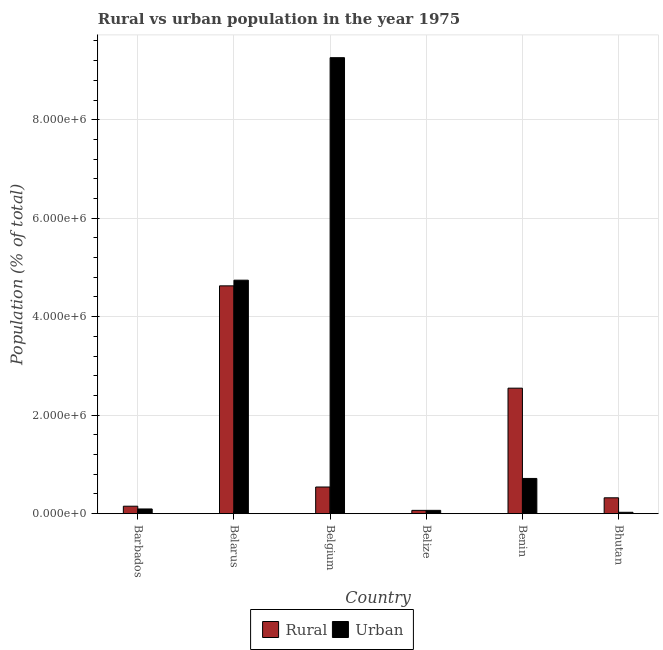How many different coloured bars are there?
Offer a terse response. 2. How many groups of bars are there?
Make the answer very short. 6. Are the number of bars on each tick of the X-axis equal?
Your response must be concise. Yes. How many bars are there on the 2nd tick from the left?
Your answer should be very brief. 2. What is the label of the 4th group of bars from the left?
Offer a terse response. Belize. What is the urban population density in Belarus?
Your answer should be very brief. 4.74e+06. Across all countries, what is the maximum urban population density?
Make the answer very short. 9.26e+06. Across all countries, what is the minimum urban population density?
Offer a terse response. 2.75e+04. In which country was the rural population density maximum?
Give a very brief answer. Belarus. In which country was the urban population density minimum?
Keep it short and to the point. Bhutan. What is the total urban population density in the graph?
Ensure brevity in your answer.  1.49e+07. What is the difference between the rural population density in Barbados and that in Belgium?
Offer a terse response. -3.90e+05. What is the difference between the rural population density in Benin and the urban population density in Belarus?
Make the answer very short. -2.19e+06. What is the average rural population density per country?
Ensure brevity in your answer.  1.38e+06. What is the difference between the urban population density and rural population density in Barbados?
Provide a short and direct response. -5.60e+04. What is the ratio of the urban population density in Barbados to that in Belgium?
Your answer should be very brief. 0.01. Is the rural population density in Benin less than that in Bhutan?
Offer a terse response. No. What is the difference between the highest and the second highest urban population density?
Ensure brevity in your answer.  4.52e+06. What is the difference between the highest and the lowest urban population density?
Your response must be concise. 9.23e+06. What does the 2nd bar from the left in Belgium represents?
Keep it short and to the point. Urban. What does the 2nd bar from the right in Bhutan represents?
Your response must be concise. Rural. How many bars are there?
Your answer should be very brief. 12. What is the difference between two consecutive major ticks on the Y-axis?
Keep it short and to the point. 2.00e+06. Does the graph contain grids?
Keep it short and to the point. Yes. Where does the legend appear in the graph?
Your answer should be very brief. Bottom center. What is the title of the graph?
Make the answer very short. Rural vs urban population in the year 1975. Does "From Government" appear as one of the legend labels in the graph?
Ensure brevity in your answer.  No. What is the label or title of the X-axis?
Ensure brevity in your answer.  Country. What is the label or title of the Y-axis?
Provide a succinct answer. Population (% of total). What is the Population (% of total) of Rural in Barbados?
Your answer should be very brief. 1.51e+05. What is the Population (% of total) in Urban in Barbados?
Make the answer very short. 9.50e+04. What is the Population (% of total) in Rural in Belarus?
Give a very brief answer. 4.63e+06. What is the Population (% of total) in Urban in Belarus?
Offer a very short reply. 4.74e+06. What is the Population (% of total) in Rural in Belgium?
Your response must be concise. 5.41e+05. What is the Population (% of total) of Urban in Belgium?
Keep it short and to the point. 9.26e+06. What is the Population (% of total) of Rural in Belize?
Your response must be concise. 6.64e+04. What is the Population (% of total) of Urban in Belize?
Your response must be concise. 6.69e+04. What is the Population (% of total) in Rural in Benin?
Your answer should be compact. 2.55e+06. What is the Population (% of total) in Urban in Benin?
Provide a short and direct response. 7.15e+05. What is the Population (% of total) of Rural in Bhutan?
Offer a terse response. 3.22e+05. What is the Population (% of total) in Urban in Bhutan?
Provide a short and direct response. 2.75e+04. Across all countries, what is the maximum Population (% of total) in Rural?
Your answer should be compact. 4.63e+06. Across all countries, what is the maximum Population (% of total) in Urban?
Provide a succinct answer. 9.26e+06. Across all countries, what is the minimum Population (% of total) in Rural?
Your answer should be compact. 6.64e+04. Across all countries, what is the minimum Population (% of total) in Urban?
Your response must be concise. 2.75e+04. What is the total Population (% of total) in Rural in the graph?
Ensure brevity in your answer.  8.25e+06. What is the total Population (% of total) in Urban in the graph?
Make the answer very short. 1.49e+07. What is the difference between the Population (% of total) in Rural in Barbados and that in Belarus?
Provide a short and direct response. -4.47e+06. What is the difference between the Population (% of total) of Urban in Barbados and that in Belarus?
Your response must be concise. -4.65e+06. What is the difference between the Population (% of total) in Rural in Barbados and that in Belgium?
Offer a terse response. -3.90e+05. What is the difference between the Population (% of total) of Urban in Barbados and that in Belgium?
Your answer should be very brief. -9.16e+06. What is the difference between the Population (% of total) of Rural in Barbados and that in Belize?
Make the answer very short. 8.46e+04. What is the difference between the Population (% of total) of Urban in Barbados and that in Belize?
Provide a succinct answer. 2.82e+04. What is the difference between the Population (% of total) of Rural in Barbados and that in Benin?
Offer a very short reply. -2.40e+06. What is the difference between the Population (% of total) of Urban in Barbados and that in Benin?
Provide a short and direct response. -6.20e+05. What is the difference between the Population (% of total) in Rural in Barbados and that in Bhutan?
Keep it short and to the point. -1.71e+05. What is the difference between the Population (% of total) in Urban in Barbados and that in Bhutan?
Your answer should be compact. 6.75e+04. What is the difference between the Population (% of total) in Rural in Belarus and that in Belgium?
Your response must be concise. 4.08e+06. What is the difference between the Population (% of total) of Urban in Belarus and that in Belgium?
Your answer should be compact. -4.52e+06. What is the difference between the Population (% of total) of Rural in Belarus and that in Belize?
Offer a terse response. 4.56e+06. What is the difference between the Population (% of total) in Urban in Belarus and that in Belize?
Make the answer very short. 4.67e+06. What is the difference between the Population (% of total) of Rural in Belarus and that in Benin?
Ensure brevity in your answer.  2.08e+06. What is the difference between the Population (% of total) of Urban in Belarus and that in Benin?
Offer a very short reply. 4.03e+06. What is the difference between the Population (% of total) of Rural in Belarus and that in Bhutan?
Give a very brief answer. 4.30e+06. What is the difference between the Population (% of total) in Urban in Belarus and that in Bhutan?
Provide a succinct answer. 4.71e+06. What is the difference between the Population (% of total) in Rural in Belgium and that in Belize?
Your answer should be compact. 4.75e+05. What is the difference between the Population (% of total) in Urban in Belgium and that in Belize?
Ensure brevity in your answer.  9.19e+06. What is the difference between the Population (% of total) of Rural in Belgium and that in Benin?
Keep it short and to the point. -2.01e+06. What is the difference between the Population (% of total) of Urban in Belgium and that in Benin?
Keep it short and to the point. 8.54e+06. What is the difference between the Population (% of total) in Rural in Belgium and that in Bhutan?
Offer a very short reply. 2.19e+05. What is the difference between the Population (% of total) of Urban in Belgium and that in Bhutan?
Ensure brevity in your answer.  9.23e+06. What is the difference between the Population (% of total) of Rural in Belize and that in Benin?
Provide a short and direct response. -2.48e+06. What is the difference between the Population (% of total) in Urban in Belize and that in Benin?
Your answer should be very brief. -6.48e+05. What is the difference between the Population (% of total) of Rural in Belize and that in Bhutan?
Provide a succinct answer. -2.55e+05. What is the difference between the Population (% of total) in Urban in Belize and that in Bhutan?
Offer a terse response. 3.94e+04. What is the difference between the Population (% of total) of Rural in Benin and that in Bhutan?
Offer a terse response. 2.23e+06. What is the difference between the Population (% of total) of Urban in Benin and that in Bhutan?
Provide a short and direct response. 6.87e+05. What is the difference between the Population (% of total) of Rural in Barbados and the Population (% of total) of Urban in Belarus?
Provide a succinct answer. -4.59e+06. What is the difference between the Population (% of total) of Rural in Barbados and the Population (% of total) of Urban in Belgium?
Your response must be concise. -9.11e+06. What is the difference between the Population (% of total) of Rural in Barbados and the Population (% of total) of Urban in Belize?
Your answer should be compact. 8.42e+04. What is the difference between the Population (% of total) in Rural in Barbados and the Population (% of total) in Urban in Benin?
Provide a short and direct response. -5.64e+05. What is the difference between the Population (% of total) of Rural in Barbados and the Population (% of total) of Urban in Bhutan?
Your answer should be compact. 1.24e+05. What is the difference between the Population (% of total) in Rural in Belarus and the Population (% of total) in Urban in Belgium?
Offer a very short reply. -4.63e+06. What is the difference between the Population (% of total) of Rural in Belarus and the Population (% of total) of Urban in Belize?
Offer a very short reply. 4.56e+06. What is the difference between the Population (% of total) in Rural in Belarus and the Population (% of total) in Urban in Benin?
Offer a very short reply. 3.91e+06. What is the difference between the Population (% of total) of Rural in Belarus and the Population (% of total) of Urban in Bhutan?
Provide a short and direct response. 4.60e+06. What is the difference between the Population (% of total) in Rural in Belgium and the Population (% of total) in Urban in Belize?
Provide a succinct answer. 4.74e+05. What is the difference between the Population (% of total) of Rural in Belgium and the Population (% of total) of Urban in Benin?
Ensure brevity in your answer.  -1.74e+05. What is the difference between the Population (% of total) in Rural in Belgium and the Population (% of total) in Urban in Bhutan?
Offer a very short reply. 5.14e+05. What is the difference between the Population (% of total) in Rural in Belize and the Population (% of total) in Urban in Benin?
Offer a very short reply. -6.48e+05. What is the difference between the Population (% of total) in Rural in Belize and the Population (% of total) in Urban in Bhutan?
Your answer should be compact. 3.89e+04. What is the difference between the Population (% of total) in Rural in Benin and the Population (% of total) in Urban in Bhutan?
Ensure brevity in your answer.  2.52e+06. What is the average Population (% of total) in Rural per country?
Give a very brief answer. 1.38e+06. What is the average Population (% of total) of Urban per country?
Make the answer very short. 2.48e+06. What is the difference between the Population (% of total) of Rural and Population (% of total) of Urban in Barbados?
Offer a very short reply. 5.60e+04. What is the difference between the Population (% of total) in Rural and Population (% of total) in Urban in Belarus?
Offer a terse response. -1.15e+05. What is the difference between the Population (% of total) of Rural and Population (% of total) of Urban in Belgium?
Provide a succinct answer. -8.72e+06. What is the difference between the Population (% of total) of Rural and Population (% of total) of Urban in Belize?
Your answer should be compact. -455. What is the difference between the Population (% of total) in Rural and Population (% of total) in Urban in Benin?
Offer a terse response. 1.83e+06. What is the difference between the Population (% of total) in Rural and Population (% of total) in Urban in Bhutan?
Make the answer very short. 2.94e+05. What is the ratio of the Population (% of total) in Rural in Barbados to that in Belarus?
Make the answer very short. 0.03. What is the ratio of the Population (% of total) of Urban in Barbados to that in Belarus?
Provide a short and direct response. 0.02. What is the ratio of the Population (% of total) of Rural in Barbados to that in Belgium?
Ensure brevity in your answer.  0.28. What is the ratio of the Population (% of total) of Urban in Barbados to that in Belgium?
Your answer should be compact. 0.01. What is the ratio of the Population (% of total) in Rural in Barbados to that in Belize?
Provide a succinct answer. 2.27. What is the ratio of the Population (% of total) in Urban in Barbados to that in Belize?
Make the answer very short. 1.42. What is the ratio of the Population (% of total) in Rural in Barbados to that in Benin?
Provide a short and direct response. 0.06. What is the ratio of the Population (% of total) in Urban in Barbados to that in Benin?
Your response must be concise. 0.13. What is the ratio of the Population (% of total) in Rural in Barbados to that in Bhutan?
Your answer should be compact. 0.47. What is the ratio of the Population (% of total) of Urban in Barbados to that in Bhutan?
Provide a short and direct response. 3.46. What is the ratio of the Population (% of total) of Rural in Belarus to that in Belgium?
Your answer should be very brief. 8.55. What is the ratio of the Population (% of total) in Urban in Belarus to that in Belgium?
Your response must be concise. 0.51. What is the ratio of the Population (% of total) of Rural in Belarus to that in Belize?
Keep it short and to the point. 69.67. What is the ratio of the Population (% of total) of Urban in Belarus to that in Belize?
Give a very brief answer. 70.91. What is the ratio of the Population (% of total) of Rural in Belarus to that in Benin?
Make the answer very short. 1.82. What is the ratio of the Population (% of total) of Urban in Belarus to that in Benin?
Provide a succinct answer. 6.63. What is the ratio of the Population (% of total) in Rural in Belarus to that in Bhutan?
Keep it short and to the point. 14.38. What is the ratio of the Population (% of total) in Urban in Belarus to that in Bhutan?
Give a very brief answer. 172.41. What is the ratio of the Population (% of total) of Rural in Belgium to that in Belize?
Make the answer very short. 8.15. What is the ratio of the Population (% of total) in Urban in Belgium to that in Belize?
Ensure brevity in your answer.  138.5. What is the ratio of the Population (% of total) in Rural in Belgium to that in Benin?
Make the answer very short. 0.21. What is the ratio of the Population (% of total) of Urban in Belgium to that in Benin?
Your answer should be compact. 12.96. What is the ratio of the Population (% of total) of Rural in Belgium to that in Bhutan?
Ensure brevity in your answer.  1.68. What is the ratio of the Population (% of total) of Urban in Belgium to that in Bhutan?
Offer a very short reply. 336.73. What is the ratio of the Population (% of total) in Rural in Belize to that in Benin?
Make the answer very short. 0.03. What is the ratio of the Population (% of total) of Urban in Belize to that in Benin?
Give a very brief answer. 0.09. What is the ratio of the Population (% of total) of Rural in Belize to that in Bhutan?
Your response must be concise. 0.21. What is the ratio of the Population (% of total) in Urban in Belize to that in Bhutan?
Provide a short and direct response. 2.43. What is the ratio of the Population (% of total) in Rural in Benin to that in Bhutan?
Offer a very short reply. 7.92. What is the ratio of the Population (% of total) of Urban in Benin to that in Bhutan?
Offer a terse response. 25.99. What is the difference between the highest and the second highest Population (% of total) in Rural?
Give a very brief answer. 2.08e+06. What is the difference between the highest and the second highest Population (% of total) in Urban?
Your answer should be compact. 4.52e+06. What is the difference between the highest and the lowest Population (% of total) in Rural?
Your answer should be compact. 4.56e+06. What is the difference between the highest and the lowest Population (% of total) of Urban?
Provide a short and direct response. 9.23e+06. 